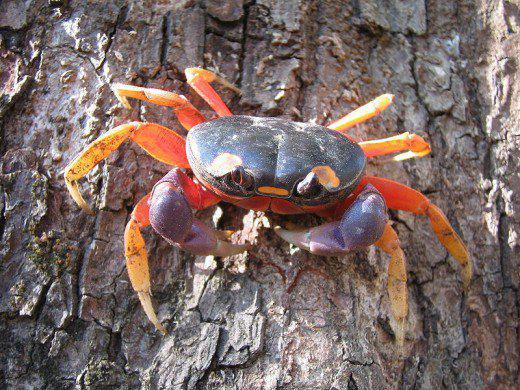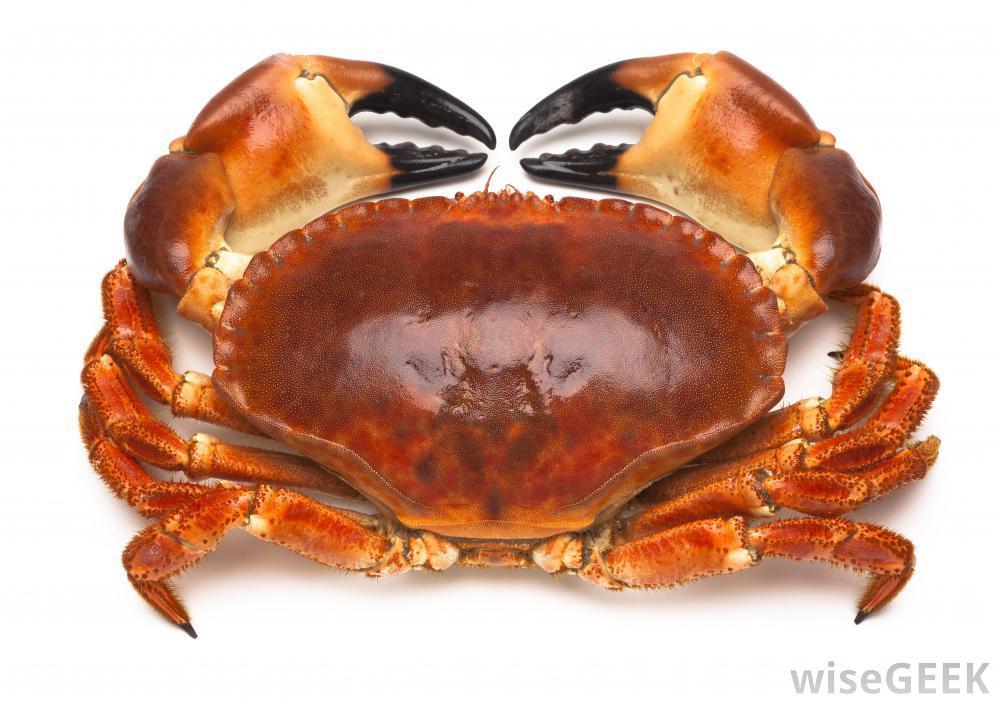The first image is the image on the left, the second image is the image on the right. Evaluate the accuracy of this statement regarding the images: "Five or fewer crab bodies are visible.". Is it true? Answer yes or no. Yes. 